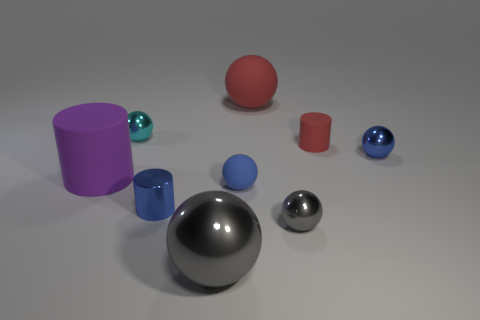How many other objects are the same shape as the tiny gray object?
Your response must be concise. 5. Is the shape of the red matte thing in front of the small cyan metallic thing the same as the tiny blue metallic object behind the small shiny cylinder?
Make the answer very short. No. What number of gray metal things are to the left of the small blue sphere on the left side of the matte sphere behind the large cylinder?
Your response must be concise. 1. The big rubber cylinder has what color?
Make the answer very short. Purple. How many other things are there of the same size as the blue rubber sphere?
Provide a succinct answer. 5. There is a red thing that is the same shape as the big purple matte object; what is it made of?
Your answer should be very brief. Rubber. What material is the small cylinder on the right side of the tiny blue metal thing that is in front of the big purple rubber thing that is to the left of the big gray metal object?
Make the answer very short. Rubber. The red ball that is the same material as the large cylinder is what size?
Offer a very short reply. Large. Are there any other things that are the same color as the small shiny cylinder?
Provide a succinct answer. Yes. There is a thing right of the small red rubber cylinder; is it the same color as the small cylinder behind the tiny metallic cylinder?
Offer a terse response. No. 